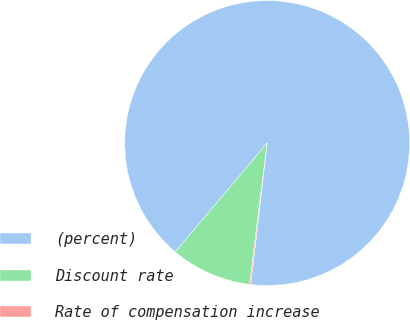<chart> <loc_0><loc_0><loc_500><loc_500><pie_chart><fcel>(percent)<fcel>Discount rate<fcel>Rate of compensation increase<nl><fcel>90.68%<fcel>9.19%<fcel>0.13%<nl></chart> 